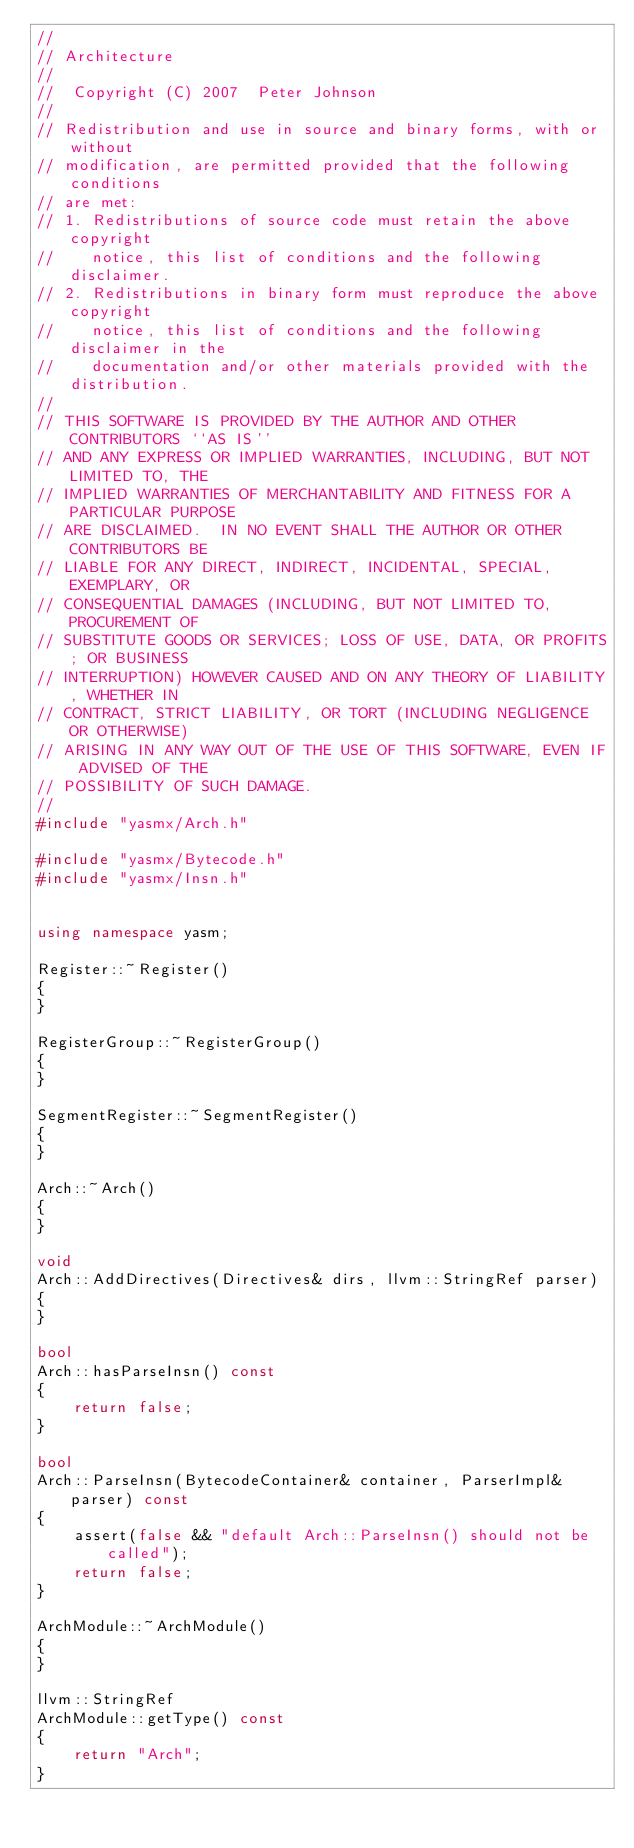Convert code to text. <code><loc_0><loc_0><loc_500><loc_500><_C++_>//
// Architecture
//
//  Copyright (C) 2007  Peter Johnson
//
// Redistribution and use in source and binary forms, with or without
// modification, are permitted provided that the following conditions
// are met:
// 1. Redistributions of source code must retain the above copyright
//    notice, this list of conditions and the following disclaimer.
// 2. Redistributions in binary form must reproduce the above copyright
//    notice, this list of conditions and the following disclaimer in the
//    documentation and/or other materials provided with the distribution.
//
// THIS SOFTWARE IS PROVIDED BY THE AUTHOR AND OTHER CONTRIBUTORS ``AS IS''
// AND ANY EXPRESS OR IMPLIED WARRANTIES, INCLUDING, BUT NOT LIMITED TO, THE
// IMPLIED WARRANTIES OF MERCHANTABILITY AND FITNESS FOR A PARTICULAR PURPOSE
// ARE DISCLAIMED.  IN NO EVENT SHALL THE AUTHOR OR OTHER CONTRIBUTORS BE
// LIABLE FOR ANY DIRECT, INDIRECT, INCIDENTAL, SPECIAL, EXEMPLARY, OR
// CONSEQUENTIAL DAMAGES (INCLUDING, BUT NOT LIMITED TO, PROCUREMENT OF
// SUBSTITUTE GOODS OR SERVICES; LOSS OF USE, DATA, OR PROFITS; OR BUSINESS
// INTERRUPTION) HOWEVER CAUSED AND ON ANY THEORY OF LIABILITY, WHETHER IN
// CONTRACT, STRICT LIABILITY, OR TORT (INCLUDING NEGLIGENCE OR OTHERWISE)
// ARISING IN ANY WAY OUT OF THE USE OF THIS SOFTWARE, EVEN IF ADVISED OF THE
// POSSIBILITY OF SUCH DAMAGE.
//
#include "yasmx/Arch.h"

#include "yasmx/Bytecode.h"
#include "yasmx/Insn.h"


using namespace yasm;

Register::~Register()
{
}

RegisterGroup::~RegisterGroup()
{
}

SegmentRegister::~SegmentRegister()
{
}

Arch::~Arch()
{
}

void
Arch::AddDirectives(Directives& dirs, llvm::StringRef parser)
{
}

bool
Arch::hasParseInsn() const
{
    return false;
}

bool
Arch::ParseInsn(BytecodeContainer& container, ParserImpl& parser) const
{
    assert(false && "default Arch::ParseInsn() should not be called");
    return false;
}

ArchModule::~ArchModule()
{
}

llvm::StringRef
ArchModule::getType() const
{
    return "Arch";
}
</code> 